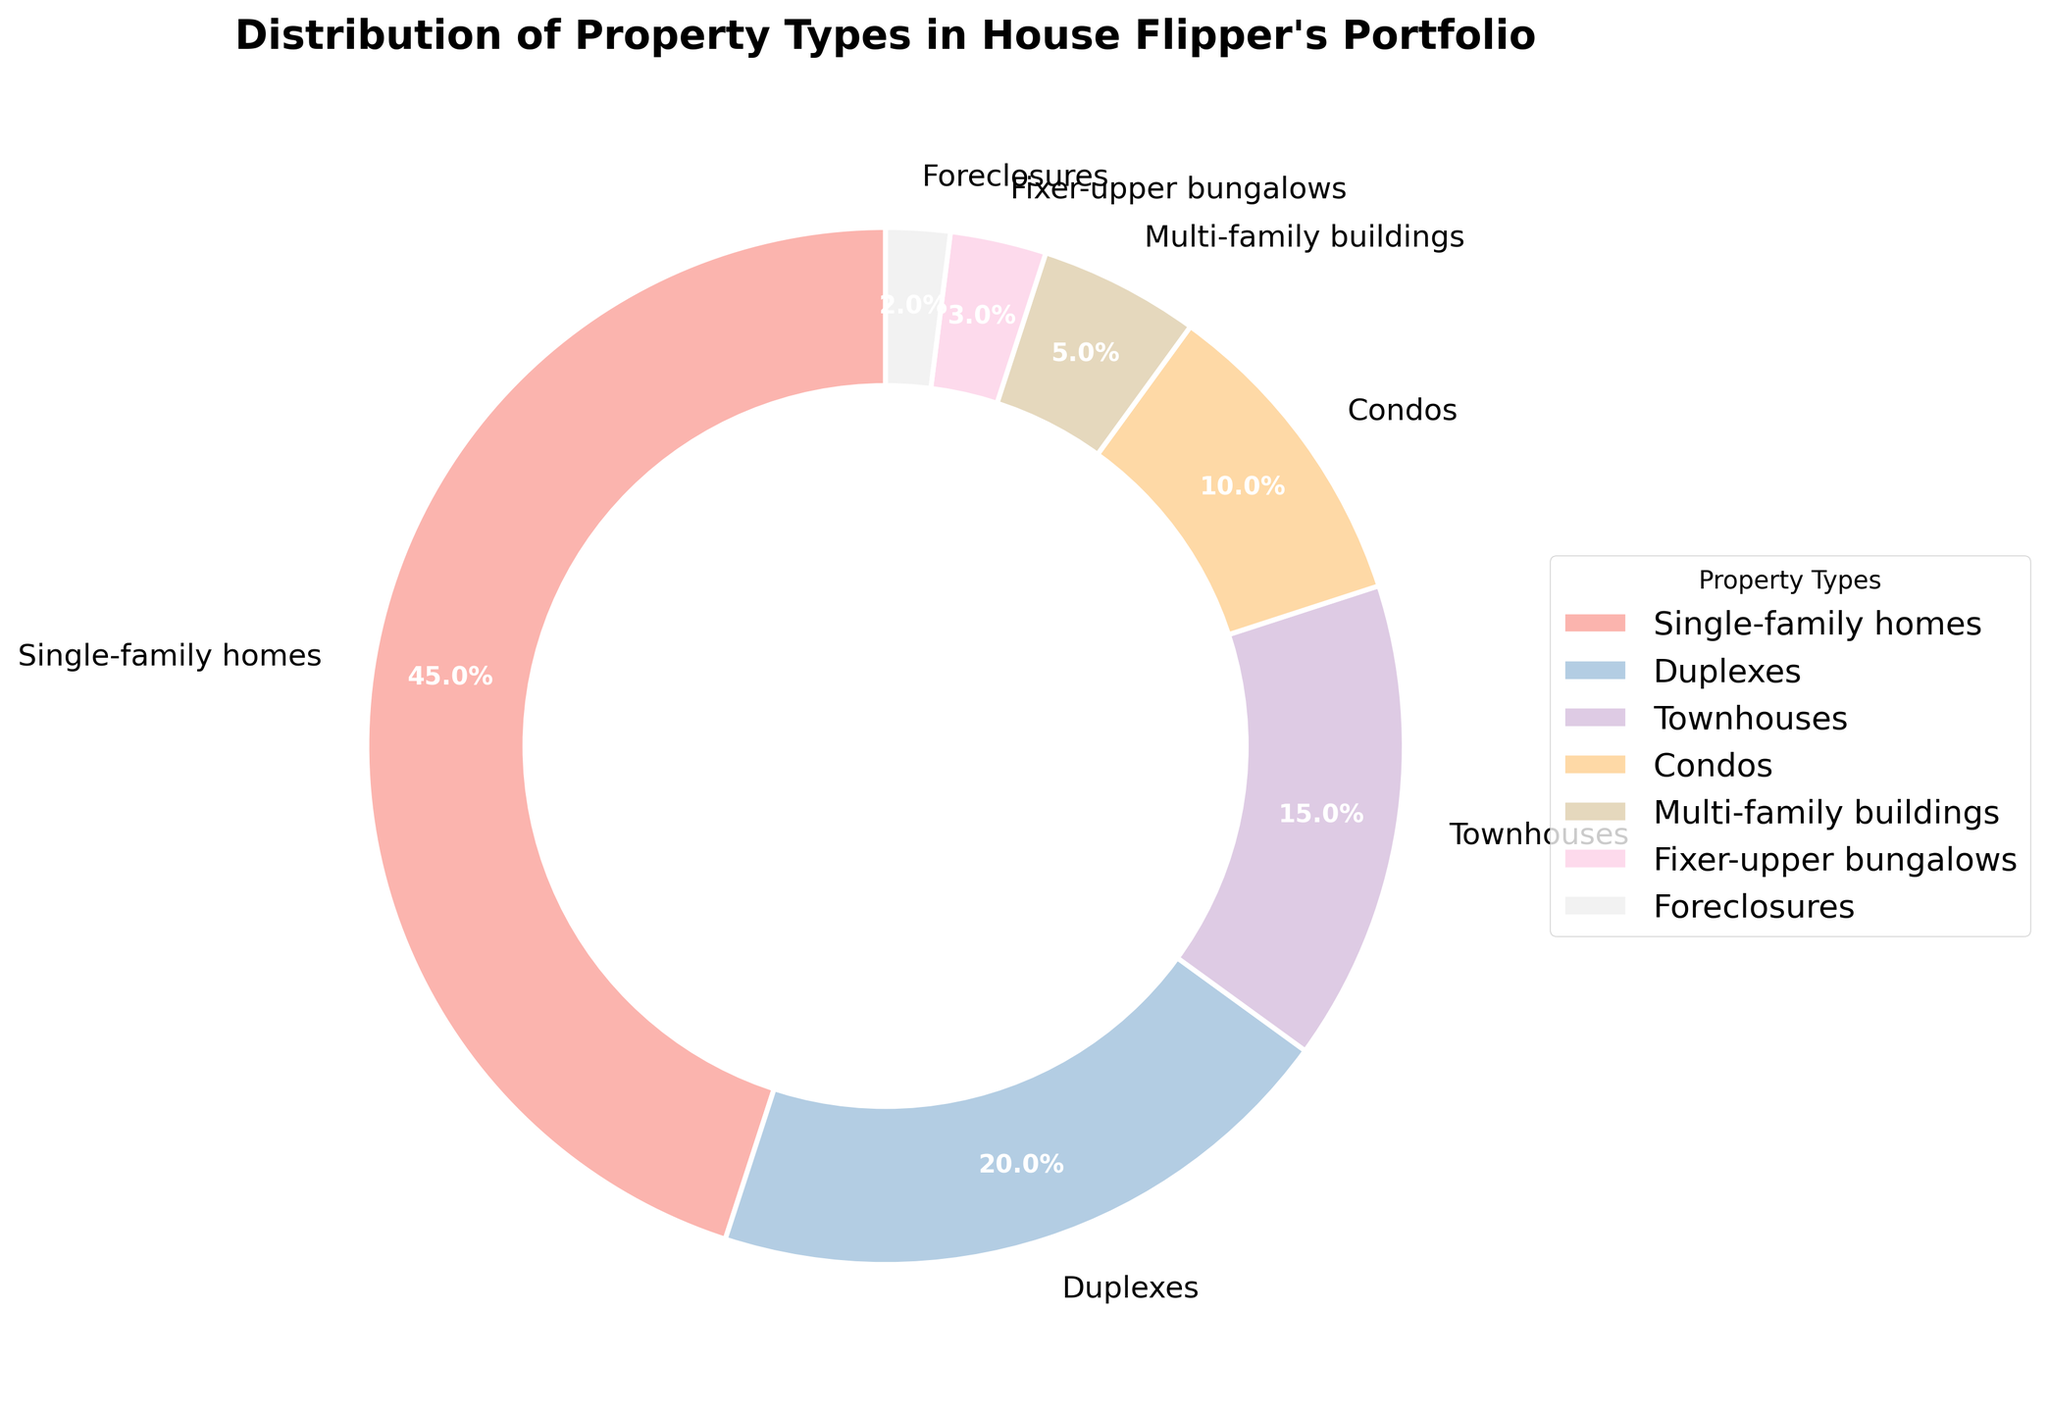What is the largest property type in the portfolio, and what percentage does it occupy? The pie chart shows that Single-family homes have the largest portion. By looking at the chart, it is 45%.
Answer: Single-family homes, 45% What is the combined percentage of Condos and Townhouses? From the pie chart, Condos are shown to occupy 10%, and Townhouses occupy 15%. Adding these two percentages gives 10% + 15% = 25%.
Answer: 25% Which property type occupies the smallest portion of the portfolio? The pie chart shows that Foreclosures have the smallest portion, at 2%.
Answer: Foreclosures, 2% How much larger is the percentage of Single-family homes compared to Fixer-upper bungalows? Single-family homes occupy 45%, and Fixer-upper bungalows occupy 3%. The difference is 45% - 3% = 42%.
Answer: 42% Are Duplexes or Townhouses more common in the portfolio, and by how much? Duplexes occupy 20%, and Townhouses occupy 15%. Duplexes are more common by a difference of 20% - 15% = 5%.
Answer: Duplexes, 5% What percentage of the portfolio is made up of Multi-family buildings and Fixer-upper bungalows combined? Multi-family buildings occupy 5%, and Fixer-upper bungalows occupy 3%. Adding these percentages gives 5% + 3% = 8%.
Answer: 8% How many property types have a percentage of 10% or less? From the pie chart, Condos (10%), Multi-family buildings (5%), Fixer-upper bungalows (3%), and Foreclosures (2%) all have percentages of 10% or less. This totals 4 property types.
Answer: 4 How much more popular are Single-family homes than Condos, Foreclosures, and Fixer-upper bungalows combined? Single-family homes occupy 45%. Condos (10%), Foreclosures (2%), and Fixer-upper bungalows (3%) combined occupy 10% + 3% + 2% = 15%. The difference is 45% - 15% = 30%.
Answer: 30% 